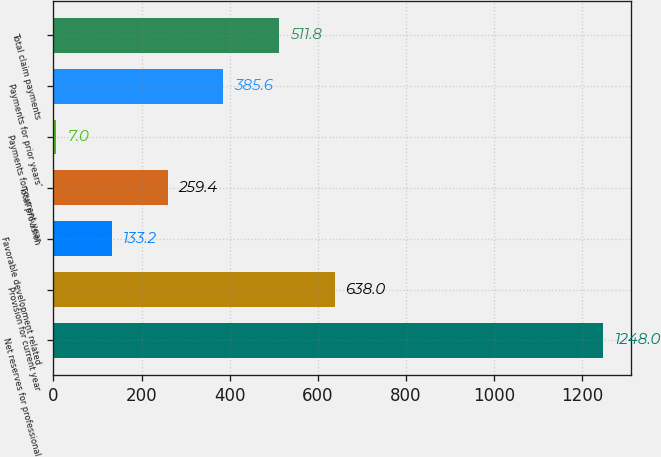Convert chart to OTSL. <chart><loc_0><loc_0><loc_500><loc_500><bar_chart><fcel>Net reserves for professional<fcel>Provision for current year<fcel>Favorable development related<fcel>Total provision<fcel>Payments for current year<fcel>Payments for prior years'<fcel>Total claim payments<nl><fcel>1248<fcel>638<fcel>133.2<fcel>259.4<fcel>7<fcel>385.6<fcel>511.8<nl></chart> 